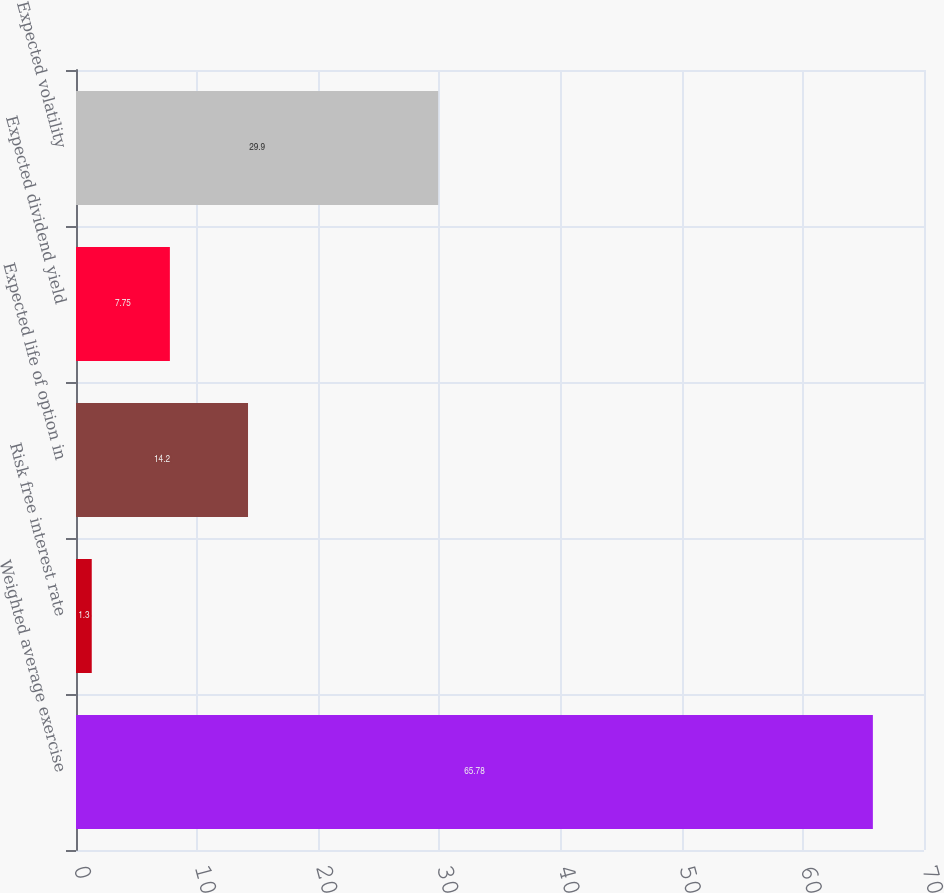Convert chart. <chart><loc_0><loc_0><loc_500><loc_500><bar_chart><fcel>Weighted average exercise<fcel>Risk free interest rate<fcel>Expected life of option in<fcel>Expected dividend yield<fcel>Expected volatility<nl><fcel>65.78<fcel>1.3<fcel>14.2<fcel>7.75<fcel>29.9<nl></chart> 